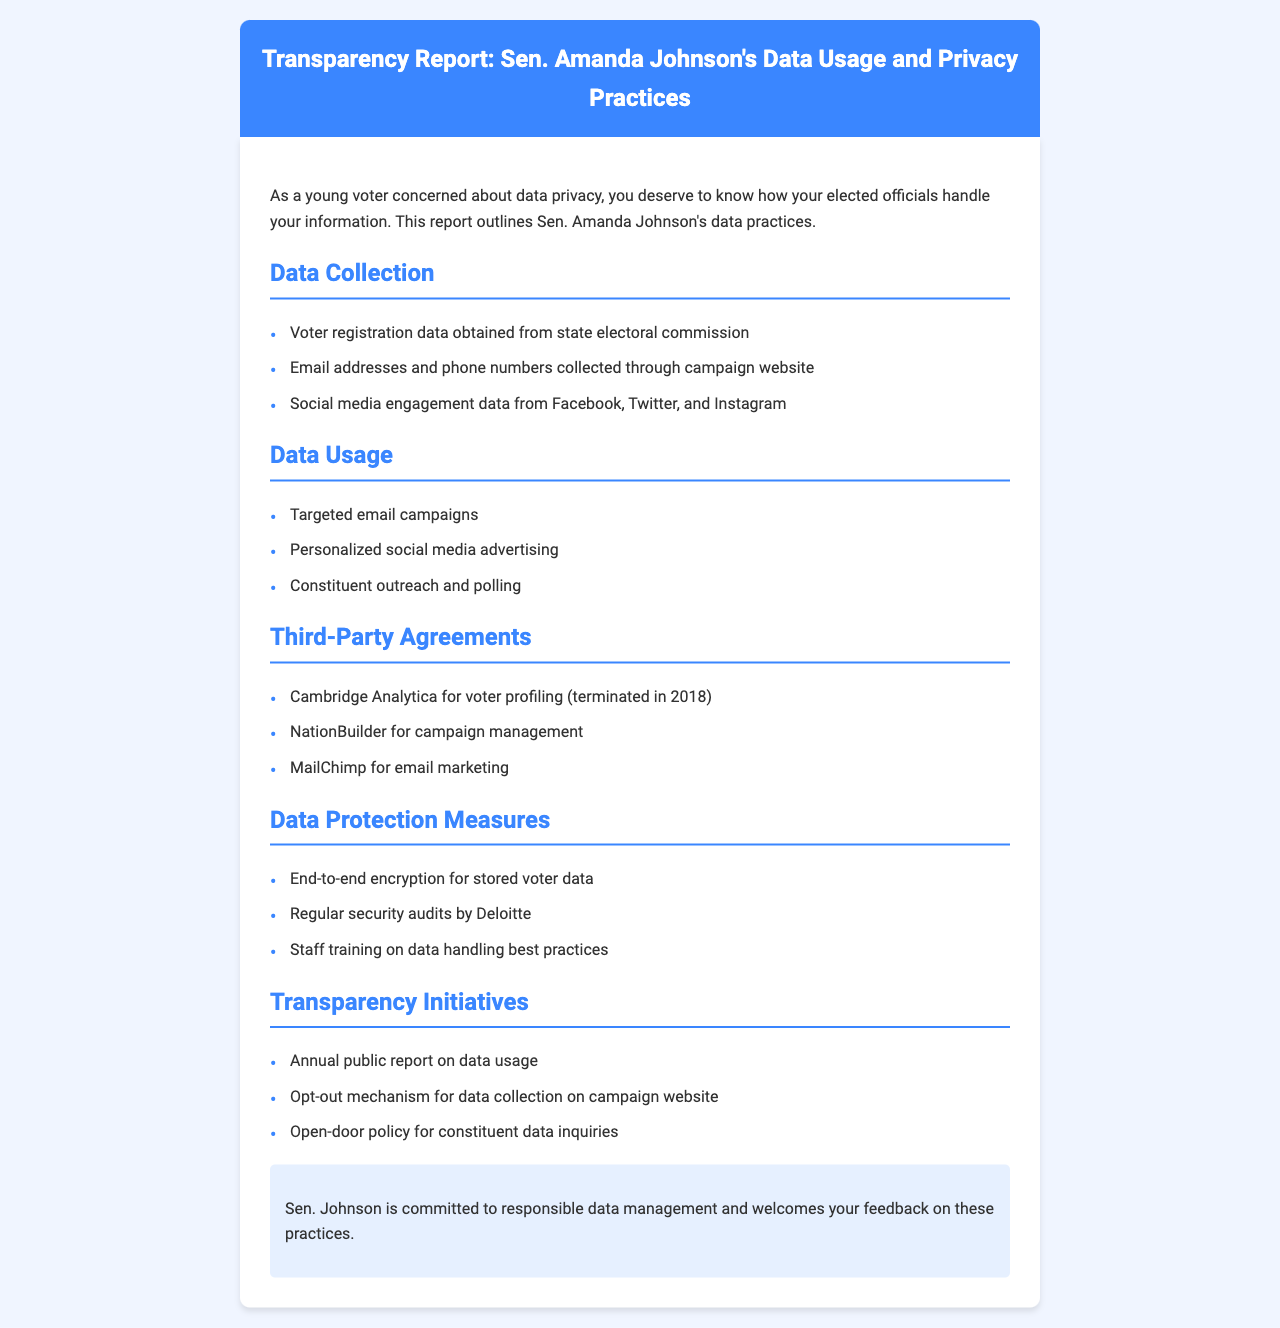What data is collected from the state electoral commission? The document states that voter registration data is obtained from the state electoral commission.
Answer: Voter registration data What is one platform used for personalized social media advertising? The document lists personalized social media advertising as part of data usage but does not specify the platforms within that point. However, it mentions social media engagement data specifically from Facebook, Twitter, and Instagram.
Answer: Facebook, Twitter, Instagram When was the agreement with Cambridge Analytica terminated? The document specifies that the agreement for voter profiling with Cambridge Analytica was terminated in 2018.
Answer: 2018 What type of audits are conducted regularly to ensure data protection? The document states that regular security audits are performed by Deloitte as a data protection measure.
Answer: Security audits What mechanism is provided for data collection opt-out? The document mentions there is an opt-out mechanism for data collection on the campaign website as part of transparency initiatives.
Answer: Campaign website What encryption is used for stored voter data? The document specifies that end-to-end encryption is used for stored voter data.
Answer: End-to-end encryption What type of report is produced annually? The document states that there is an annual public report on data usage as part of transparency initiatives.
Answer: Annual public report Who conducts the security audits mentioned in the document? The document specifies that the security audits are conducted by Deloitte.
Answer: Deloitte 